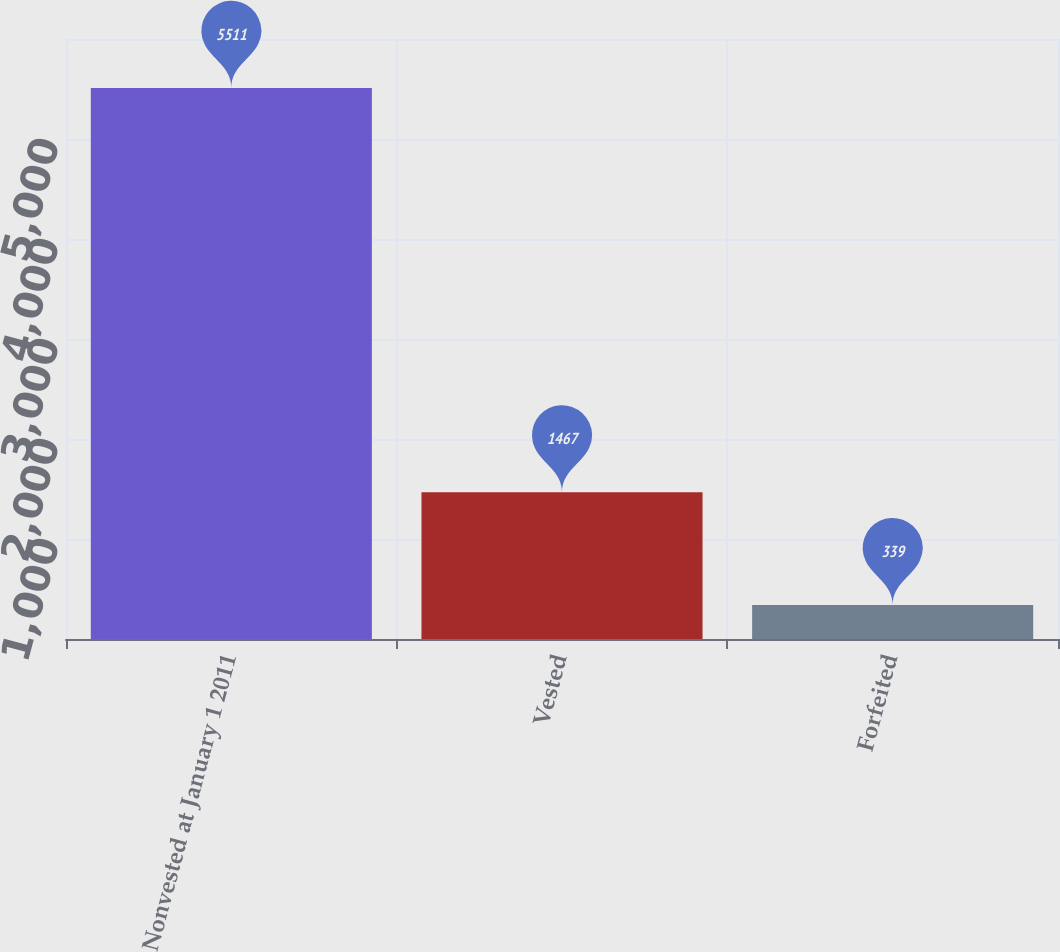<chart> <loc_0><loc_0><loc_500><loc_500><bar_chart><fcel>Nonvested at January 1 2011<fcel>Vested<fcel>Forfeited<nl><fcel>5511<fcel>1467<fcel>339<nl></chart> 